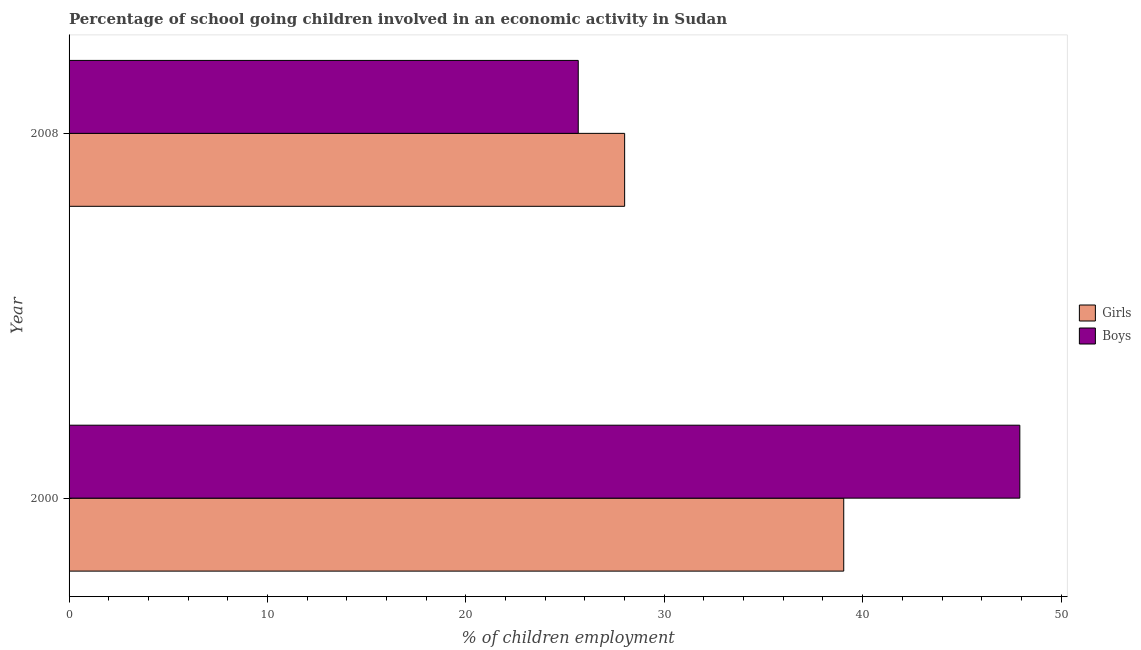How many different coloured bars are there?
Provide a succinct answer. 2. How many groups of bars are there?
Give a very brief answer. 2. Are the number of bars on each tick of the Y-axis equal?
Provide a short and direct response. Yes. How many bars are there on the 1st tick from the top?
Provide a succinct answer. 2. How many bars are there on the 1st tick from the bottom?
Your answer should be compact. 2. What is the label of the 1st group of bars from the top?
Provide a short and direct response. 2008. What is the percentage of school going boys in 2000?
Your answer should be compact. 47.92. Across all years, what is the maximum percentage of school going girls?
Make the answer very short. 39.05. Across all years, what is the minimum percentage of school going girls?
Your response must be concise. 28. In which year was the percentage of school going boys minimum?
Keep it short and to the point. 2008. What is the total percentage of school going girls in the graph?
Provide a short and direct response. 67.05. What is the difference between the percentage of school going boys in 2000 and that in 2008?
Provide a short and direct response. 22.26. What is the difference between the percentage of school going boys in 2000 and the percentage of school going girls in 2008?
Provide a succinct answer. 19.92. What is the average percentage of school going girls per year?
Offer a very short reply. 33.52. In the year 2000, what is the difference between the percentage of school going girls and percentage of school going boys?
Make the answer very short. -8.88. In how many years, is the percentage of school going girls greater than 22 %?
Make the answer very short. 2. What is the ratio of the percentage of school going girls in 2000 to that in 2008?
Make the answer very short. 1.39. Is the percentage of school going girls in 2000 less than that in 2008?
Offer a terse response. No. In how many years, is the percentage of school going boys greater than the average percentage of school going boys taken over all years?
Offer a terse response. 1. What does the 2nd bar from the top in 2000 represents?
Offer a terse response. Girls. What does the 1st bar from the bottom in 2008 represents?
Provide a short and direct response. Girls. Are all the bars in the graph horizontal?
Your answer should be compact. Yes. Are the values on the major ticks of X-axis written in scientific E-notation?
Your answer should be compact. No. Does the graph contain any zero values?
Provide a succinct answer. No. How many legend labels are there?
Provide a succinct answer. 2. What is the title of the graph?
Your answer should be very brief. Percentage of school going children involved in an economic activity in Sudan. What is the label or title of the X-axis?
Offer a terse response. % of children employment. What is the label or title of the Y-axis?
Offer a terse response. Year. What is the % of children employment in Girls in 2000?
Your answer should be compact. 39.05. What is the % of children employment of Boys in 2000?
Offer a terse response. 47.92. What is the % of children employment of Girls in 2008?
Make the answer very short. 28. What is the % of children employment of Boys in 2008?
Offer a very short reply. 25.67. Across all years, what is the maximum % of children employment of Girls?
Provide a short and direct response. 39.05. Across all years, what is the maximum % of children employment in Boys?
Offer a very short reply. 47.92. Across all years, what is the minimum % of children employment in Girls?
Ensure brevity in your answer.  28. Across all years, what is the minimum % of children employment in Boys?
Ensure brevity in your answer.  25.67. What is the total % of children employment in Girls in the graph?
Your answer should be very brief. 67.05. What is the total % of children employment of Boys in the graph?
Your response must be concise. 73.59. What is the difference between the % of children employment in Girls in 2000 and that in 2008?
Keep it short and to the point. 11.04. What is the difference between the % of children employment of Boys in 2000 and that in 2008?
Provide a succinct answer. 22.26. What is the difference between the % of children employment in Girls in 2000 and the % of children employment in Boys in 2008?
Your response must be concise. 13.38. What is the average % of children employment of Girls per year?
Ensure brevity in your answer.  33.52. What is the average % of children employment in Boys per year?
Give a very brief answer. 36.79. In the year 2000, what is the difference between the % of children employment in Girls and % of children employment in Boys?
Keep it short and to the point. -8.88. In the year 2008, what is the difference between the % of children employment of Girls and % of children employment of Boys?
Provide a short and direct response. 2.34. What is the ratio of the % of children employment in Girls in 2000 to that in 2008?
Offer a terse response. 1.39. What is the ratio of the % of children employment of Boys in 2000 to that in 2008?
Provide a succinct answer. 1.87. What is the difference between the highest and the second highest % of children employment in Girls?
Ensure brevity in your answer.  11.04. What is the difference between the highest and the second highest % of children employment of Boys?
Offer a terse response. 22.26. What is the difference between the highest and the lowest % of children employment in Girls?
Offer a very short reply. 11.04. What is the difference between the highest and the lowest % of children employment in Boys?
Your answer should be compact. 22.26. 